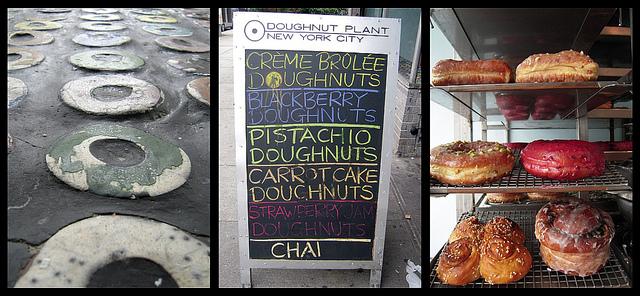What city is the picture taken?
Keep it brief. New york. Is the sign typed or handwritten?
Write a very short answer. Handwritten. How many separate pictures are in this image?
Answer briefly. 3. 